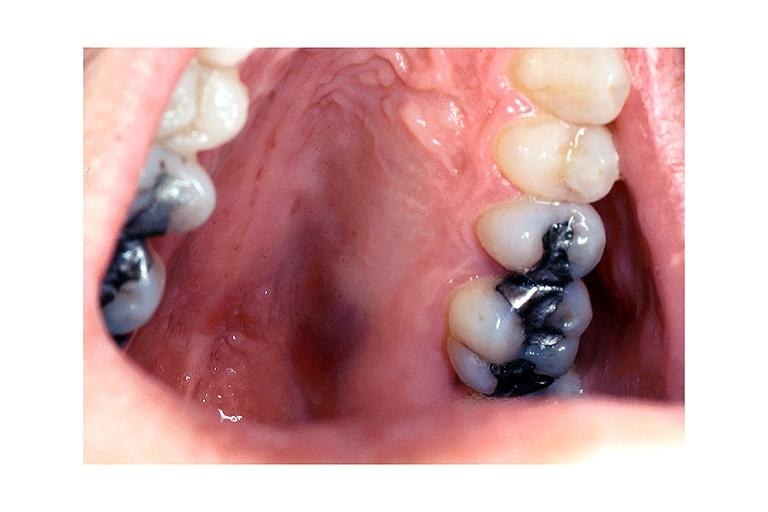does this image show kaposi sarcoma?
Answer the question using a single word or phrase. Yes 